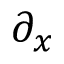<formula> <loc_0><loc_0><loc_500><loc_500>\partial _ { x }</formula> 